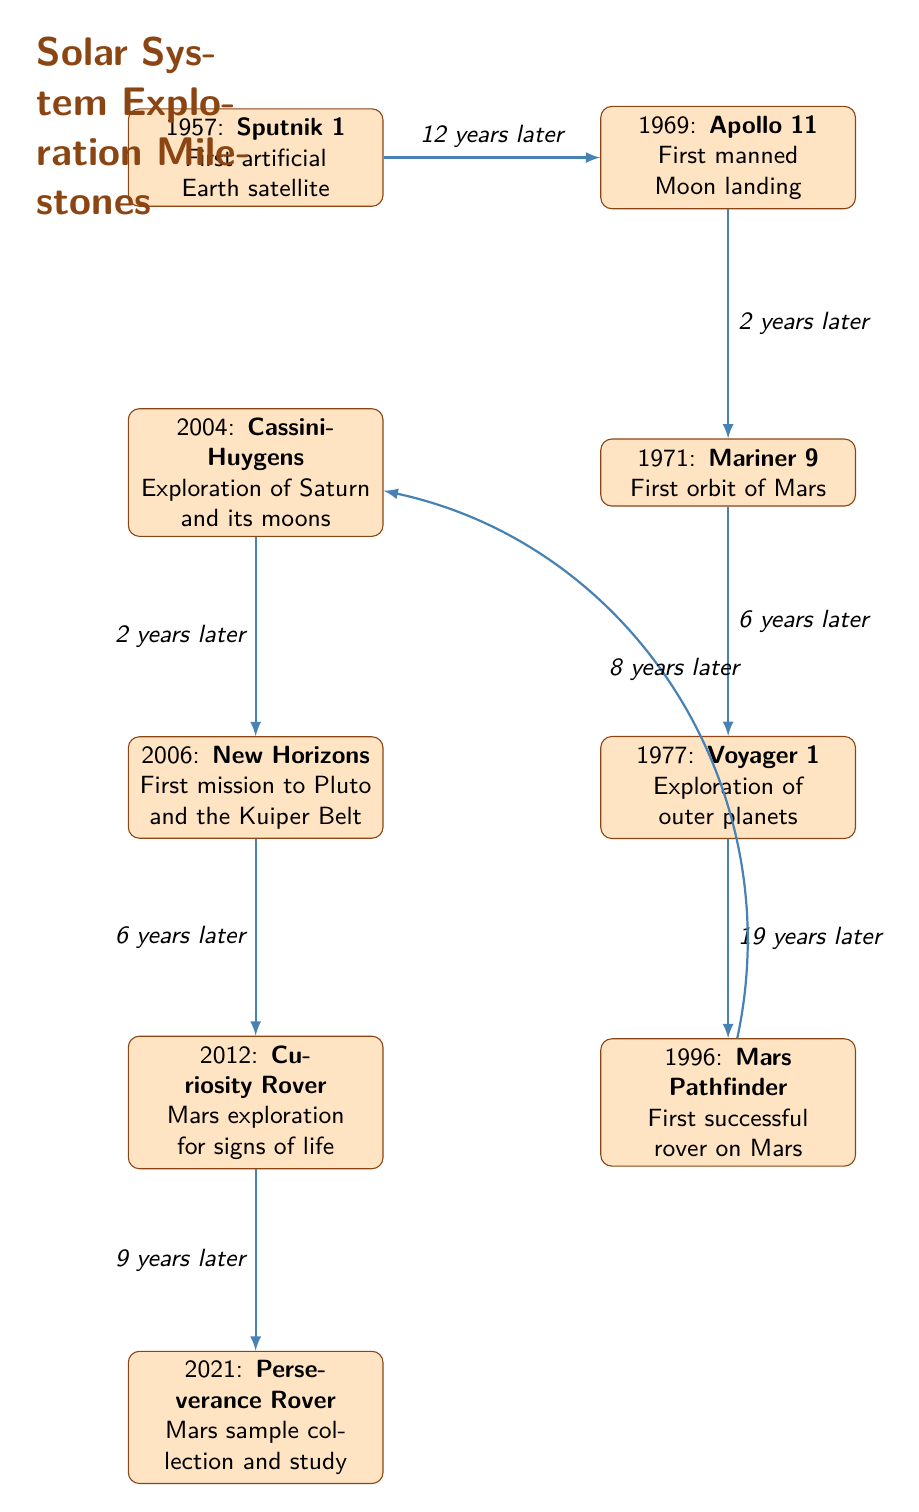What is the first mission highlighted in the diagram? From the diagram, the first mission listed is "Sputnik 1," dated 1957. It is positioned at the top of the timeline, indicating it is the earliest event in solar system exploration highlighted here.
Answer: Sputnik 1 How many Mars missions are listed in the diagram? The diagram shows three Mars-related missions: "Mariner 9" in 1971, "Mars Pathfinder" in 1996, and "Curiosity Rover" in 2012, along with "Perseverance Rover" in 2021. Counting these missions totals four distinct entries.
Answer: 4 What major milestone followed the Apollo 11 mission? Following "Apollo 11" in 1969, "Mariner 9," which signifies the first orbit of Mars, is listed as the next mission. The positioning directly below indicates a timeline relationship, occurring two years later in 1971.
Answer: Mariner 9 How many years passed between Voyager 1 and Mars Pathfinder? "Voyager 1" is dated 1977 while "Mars Pathfinder" happens in 1996. The number of years between them can be calculated by subtracting the dates (1996 - 1977), resulting in 19 years.
Answer: 19 years Which mission is specifically related to Pluto? The mission that is specifically aiming at Pluto is "New Horizons," launched in 2006 and is noted as the first mission to Pluto and the Kuiper Belt within the diagram. This designation makes it the key mission associated with Pluto exploration.
Answer: New Horizons What is the last mission depicted in the diagram? The diagram concludes with "Perseverance Rover," which is shown at the bottom with the year 2021 listed next to it. This positioning signifies it as the most recent milestone highlighted in the context of solar system exploration.
Answer: Perseverance Rover Which mission represents the first successful rover on Mars? The "Mars Pathfinder," which is highlighted in 1996, is identified as the first successful rover on Mars according to this timeline. It is positioned below the earlier missions, marking it as a significant milestone in Mars exploration.
Answer: Mars Pathfinder What is the time gap between Cassini-Huygens and New Horizons? "Cassini-Huygens" is labeled 2004 and "New Horizons" follows in 2006. By subtracting these years (2006 - 2004), we find that the time gap is two years, indicating a relatively short period between these two missions.
Answer: 2 years 